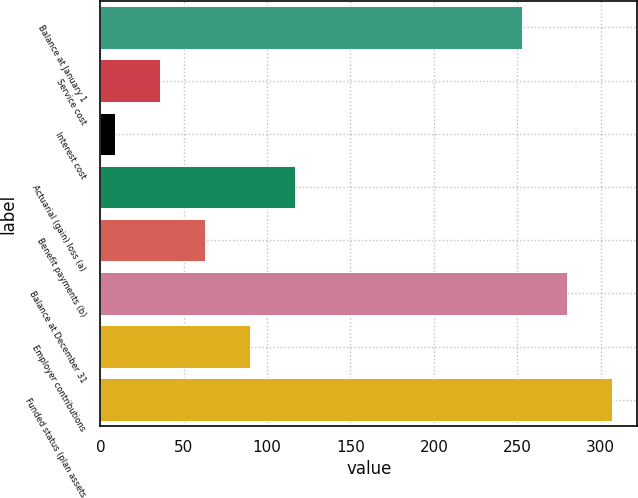Convert chart. <chart><loc_0><loc_0><loc_500><loc_500><bar_chart><fcel>Balance at January 1<fcel>Service cost<fcel>Interest cost<fcel>Actuarial (gain) loss (a)<fcel>Benefit payments (b)<fcel>Balance at December 31<fcel>Employer contributions<fcel>Funded status (plan assets<nl><fcel>253<fcel>35.9<fcel>9<fcel>116.6<fcel>62.8<fcel>279.9<fcel>89.7<fcel>306.8<nl></chart> 